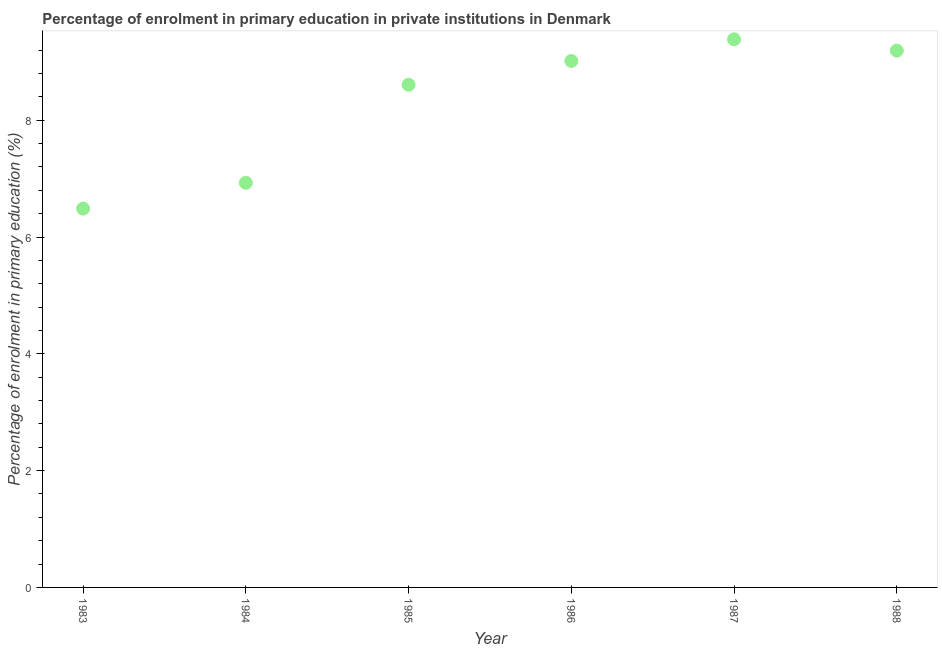What is the enrolment percentage in primary education in 1986?
Keep it short and to the point. 9.02. Across all years, what is the maximum enrolment percentage in primary education?
Keep it short and to the point. 9.39. Across all years, what is the minimum enrolment percentage in primary education?
Provide a succinct answer. 6.49. In which year was the enrolment percentage in primary education minimum?
Provide a short and direct response. 1983. What is the sum of the enrolment percentage in primary education?
Give a very brief answer. 49.62. What is the difference between the enrolment percentage in primary education in 1985 and 1988?
Your response must be concise. -0.58. What is the average enrolment percentage in primary education per year?
Ensure brevity in your answer.  8.27. What is the median enrolment percentage in primary education?
Your answer should be compact. 8.81. In how many years, is the enrolment percentage in primary education greater than 7.2 %?
Offer a very short reply. 4. What is the ratio of the enrolment percentage in primary education in 1983 to that in 1986?
Provide a short and direct response. 0.72. What is the difference between the highest and the second highest enrolment percentage in primary education?
Offer a terse response. 0.19. Is the sum of the enrolment percentage in primary education in 1984 and 1986 greater than the maximum enrolment percentage in primary education across all years?
Keep it short and to the point. Yes. What is the difference between the highest and the lowest enrolment percentage in primary education?
Give a very brief answer. 2.9. In how many years, is the enrolment percentage in primary education greater than the average enrolment percentage in primary education taken over all years?
Your answer should be very brief. 4. Does the enrolment percentage in primary education monotonically increase over the years?
Offer a very short reply. No. How many dotlines are there?
Offer a terse response. 1. Does the graph contain any zero values?
Provide a succinct answer. No. Does the graph contain grids?
Offer a terse response. No. What is the title of the graph?
Your answer should be very brief. Percentage of enrolment in primary education in private institutions in Denmark. What is the label or title of the X-axis?
Your answer should be very brief. Year. What is the label or title of the Y-axis?
Provide a short and direct response. Percentage of enrolment in primary education (%). What is the Percentage of enrolment in primary education (%) in 1983?
Ensure brevity in your answer.  6.49. What is the Percentage of enrolment in primary education (%) in 1984?
Keep it short and to the point. 6.93. What is the Percentage of enrolment in primary education (%) in 1985?
Make the answer very short. 8.61. What is the Percentage of enrolment in primary education (%) in 1986?
Your answer should be very brief. 9.02. What is the Percentage of enrolment in primary education (%) in 1987?
Offer a terse response. 9.39. What is the Percentage of enrolment in primary education (%) in 1988?
Keep it short and to the point. 9.19. What is the difference between the Percentage of enrolment in primary education (%) in 1983 and 1984?
Your answer should be compact. -0.44. What is the difference between the Percentage of enrolment in primary education (%) in 1983 and 1985?
Your response must be concise. -2.12. What is the difference between the Percentage of enrolment in primary education (%) in 1983 and 1986?
Provide a succinct answer. -2.53. What is the difference between the Percentage of enrolment in primary education (%) in 1983 and 1987?
Your response must be concise. -2.9. What is the difference between the Percentage of enrolment in primary education (%) in 1983 and 1988?
Your answer should be compact. -2.7. What is the difference between the Percentage of enrolment in primary education (%) in 1984 and 1985?
Offer a very short reply. -1.68. What is the difference between the Percentage of enrolment in primary education (%) in 1984 and 1986?
Make the answer very short. -2.09. What is the difference between the Percentage of enrolment in primary education (%) in 1984 and 1987?
Your answer should be compact. -2.46. What is the difference between the Percentage of enrolment in primary education (%) in 1984 and 1988?
Ensure brevity in your answer.  -2.26. What is the difference between the Percentage of enrolment in primary education (%) in 1985 and 1986?
Make the answer very short. -0.41. What is the difference between the Percentage of enrolment in primary education (%) in 1985 and 1987?
Make the answer very short. -0.78. What is the difference between the Percentage of enrolment in primary education (%) in 1985 and 1988?
Give a very brief answer. -0.58. What is the difference between the Percentage of enrolment in primary education (%) in 1986 and 1987?
Provide a succinct answer. -0.37. What is the difference between the Percentage of enrolment in primary education (%) in 1986 and 1988?
Your answer should be compact. -0.18. What is the difference between the Percentage of enrolment in primary education (%) in 1987 and 1988?
Your answer should be compact. 0.19. What is the ratio of the Percentage of enrolment in primary education (%) in 1983 to that in 1984?
Keep it short and to the point. 0.94. What is the ratio of the Percentage of enrolment in primary education (%) in 1983 to that in 1985?
Provide a succinct answer. 0.75. What is the ratio of the Percentage of enrolment in primary education (%) in 1983 to that in 1986?
Give a very brief answer. 0.72. What is the ratio of the Percentage of enrolment in primary education (%) in 1983 to that in 1987?
Your answer should be compact. 0.69. What is the ratio of the Percentage of enrolment in primary education (%) in 1983 to that in 1988?
Your answer should be compact. 0.71. What is the ratio of the Percentage of enrolment in primary education (%) in 1984 to that in 1985?
Offer a very short reply. 0.81. What is the ratio of the Percentage of enrolment in primary education (%) in 1984 to that in 1986?
Offer a terse response. 0.77. What is the ratio of the Percentage of enrolment in primary education (%) in 1984 to that in 1987?
Your answer should be very brief. 0.74. What is the ratio of the Percentage of enrolment in primary education (%) in 1984 to that in 1988?
Offer a very short reply. 0.75. What is the ratio of the Percentage of enrolment in primary education (%) in 1985 to that in 1986?
Your answer should be very brief. 0.95. What is the ratio of the Percentage of enrolment in primary education (%) in 1985 to that in 1987?
Make the answer very short. 0.92. What is the ratio of the Percentage of enrolment in primary education (%) in 1985 to that in 1988?
Provide a succinct answer. 0.94. What is the ratio of the Percentage of enrolment in primary education (%) in 1986 to that in 1987?
Make the answer very short. 0.96. What is the ratio of the Percentage of enrolment in primary education (%) in 1986 to that in 1988?
Your response must be concise. 0.98. 